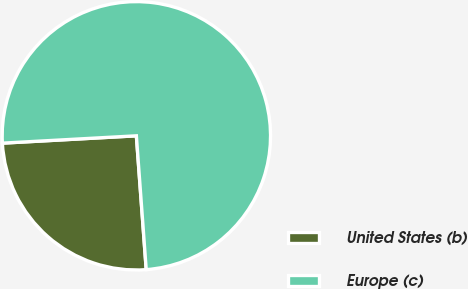Convert chart to OTSL. <chart><loc_0><loc_0><loc_500><loc_500><pie_chart><fcel>United States (b)<fcel>Europe (c)<nl><fcel>25.3%<fcel>74.7%<nl></chart> 